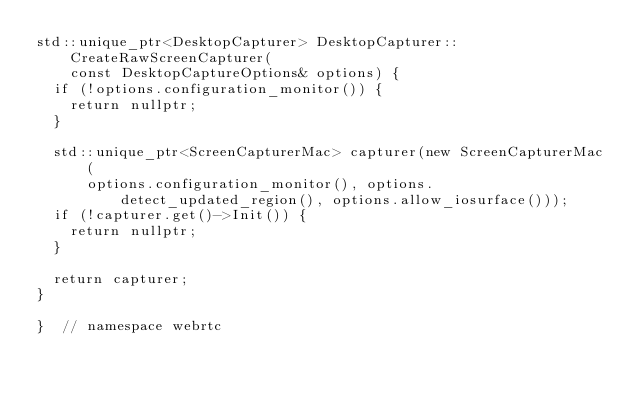Convert code to text. <code><loc_0><loc_0><loc_500><loc_500><_ObjectiveC_>std::unique_ptr<DesktopCapturer> DesktopCapturer::CreateRawScreenCapturer(
    const DesktopCaptureOptions& options) {
  if (!options.configuration_monitor()) {
    return nullptr;
  }

  std::unique_ptr<ScreenCapturerMac> capturer(new ScreenCapturerMac(
      options.configuration_monitor(), options.detect_updated_region(), options.allow_iosurface()));
  if (!capturer.get()->Init()) {
    return nullptr;
  }

  return capturer;
}

}  // namespace webrtc
</code> 